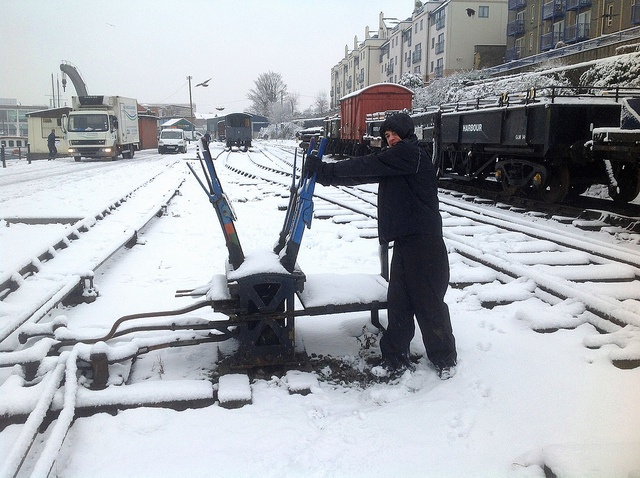Describe the objects in this image and their specific colors. I can see train in lightgray, black, darkgray, and gray tones, people in lightgray, black, gray, and darkgray tones, train in lightgray, maroon, gray, black, and brown tones, truck in lightgray, gray, and darkgray tones, and train in lightgray, gray, and black tones in this image. 